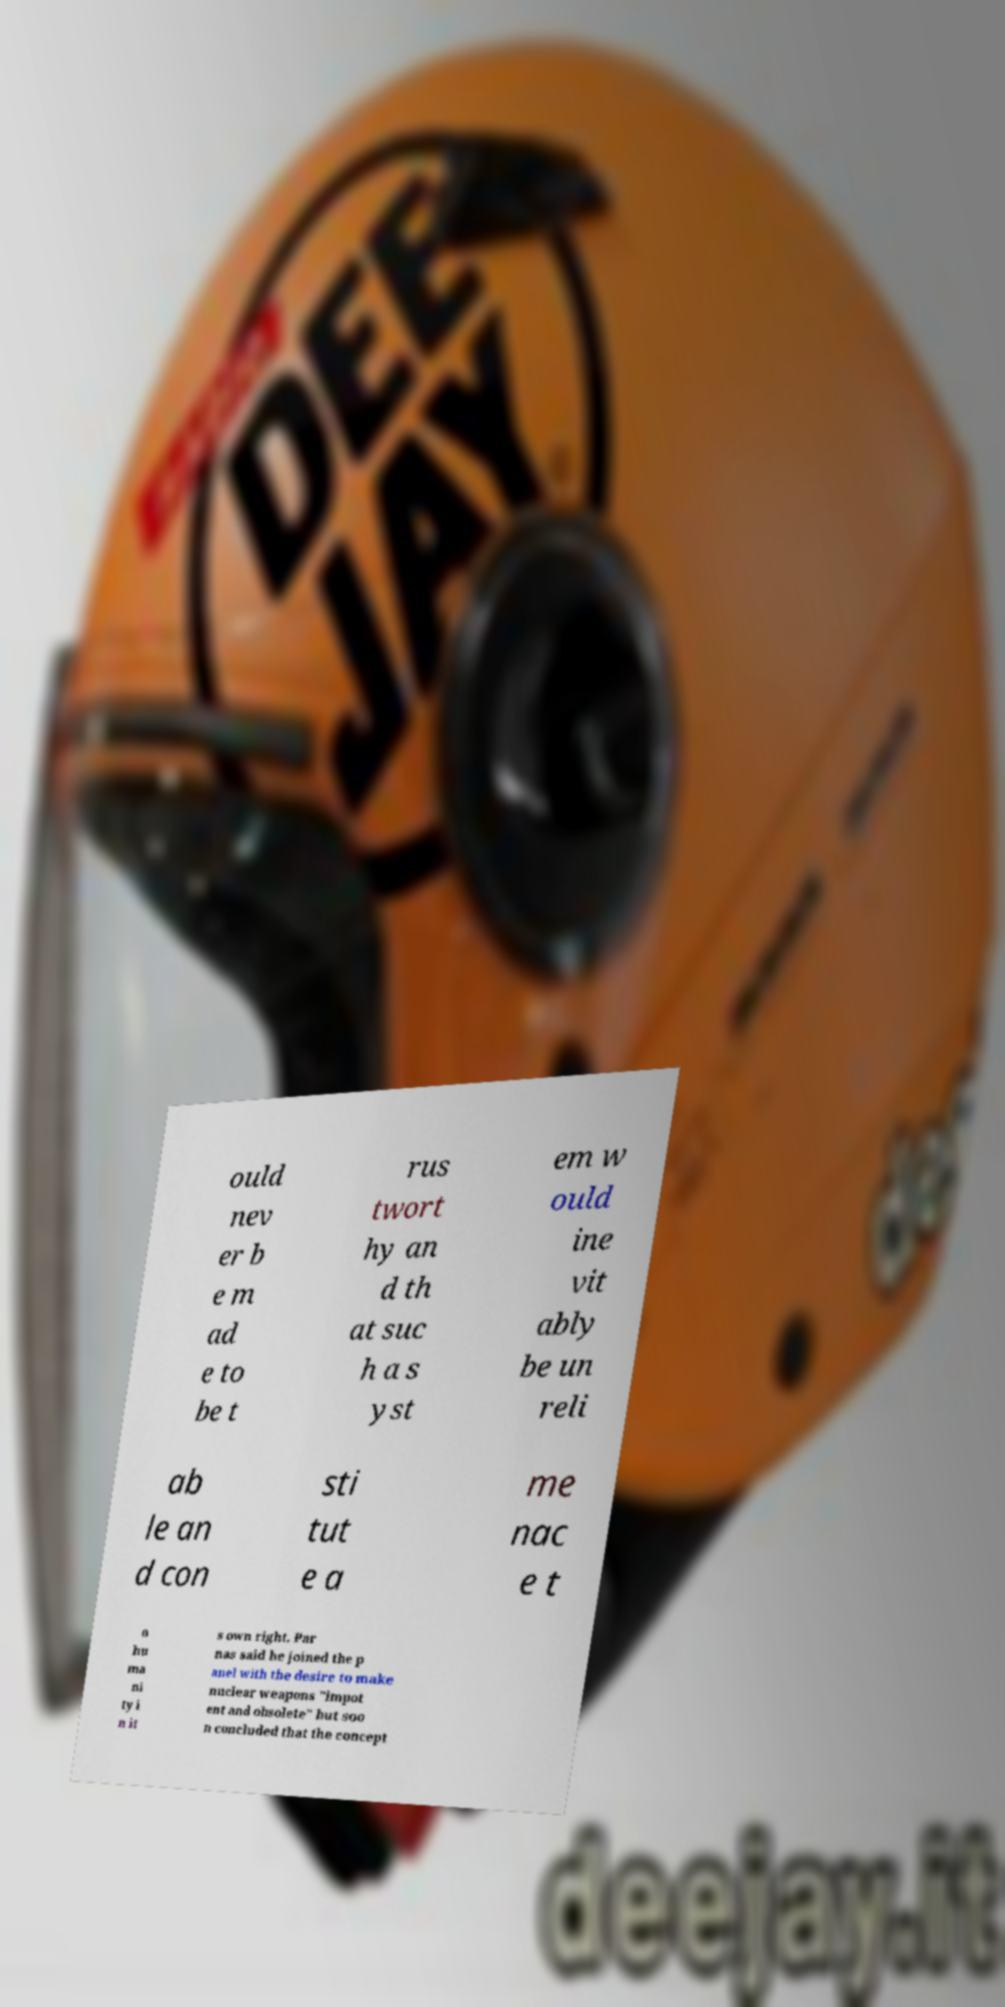Please read and relay the text visible in this image. What does it say? ould nev er b e m ad e to be t rus twort hy an d th at suc h a s yst em w ould ine vit ably be un reli ab le an d con sti tut e a me nac e t o hu ma ni ty i n it s own right. Par nas said he joined the p anel with the desire to make nuclear weapons "impot ent and obsolete" but soo n concluded that the concept 